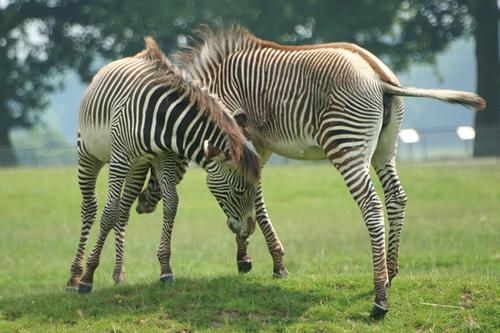Are the zebras fighting?
Write a very short answer. No. Where is the sun relative to the zebras?
Be succinct. Above. How many hooves are on the zebra?
Be succinct. 4. 